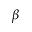Convert formula to latex. <formula><loc_0><loc_0><loc_500><loc_500>\beta</formula> 